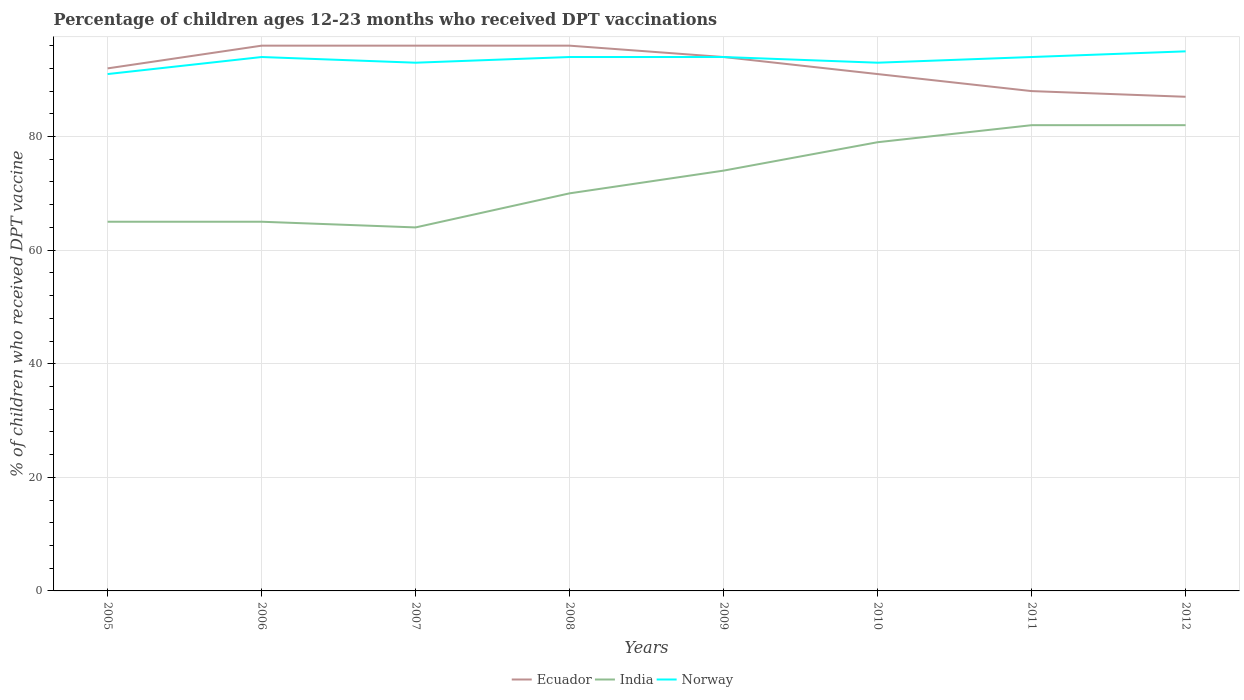Does the line corresponding to Ecuador intersect with the line corresponding to Norway?
Your answer should be compact. Yes. Across all years, what is the maximum percentage of children who received DPT vaccination in Ecuador?
Keep it short and to the point. 87. In which year was the percentage of children who received DPT vaccination in Norway maximum?
Give a very brief answer. 2005. What is the total percentage of children who received DPT vaccination in Ecuador in the graph?
Make the answer very short. 4. What is the difference between the highest and the second highest percentage of children who received DPT vaccination in India?
Provide a short and direct response. 18. What is the difference between the highest and the lowest percentage of children who received DPT vaccination in India?
Provide a short and direct response. 4. Is the percentage of children who received DPT vaccination in India strictly greater than the percentage of children who received DPT vaccination in Norway over the years?
Provide a short and direct response. Yes. Are the values on the major ticks of Y-axis written in scientific E-notation?
Provide a succinct answer. No. Does the graph contain any zero values?
Provide a succinct answer. No. Does the graph contain grids?
Provide a short and direct response. Yes. How many legend labels are there?
Keep it short and to the point. 3. How are the legend labels stacked?
Your response must be concise. Horizontal. What is the title of the graph?
Your answer should be very brief. Percentage of children ages 12-23 months who received DPT vaccinations. What is the label or title of the Y-axis?
Make the answer very short. % of children who received DPT vaccine. What is the % of children who received DPT vaccine in Ecuador in 2005?
Your answer should be very brief. 92. What is the % of children who received DPT vaccine in Norway in 2005?
Offer a very short reply. 91. What is the % of children who received DPT vaccine of Ecuador in 2006?
Your response must be concise. 96. What is the % of children who received DPT vaccine of India in 2006?
Your answer should be compact. 65. What is the % of children who received DPT vaccine of Norway in 2006?
Keep it short and to the point. 94. What is the % of children who received DPT vaccine in Ecuador in 2007?
Your answer should be very brief. 96. What is the % of children who received DPT vaccine in India in 2007?
Make the answer very short. 64. What is the % of children who received DPT vaccine of Norway in 2007?
Your answer should be very brief. 93. What is the % of children who received DPT vaccine in Ecuador in 2008?
Your answer should be compact. 96. What is the % of children who received DPT vaccine of Norway in 2008?
Your response must be concise. 94. What is the % of children who received DPT vaccine of Ecuador in 2009?
Provide a short and direct response. 94. What is the % of children who received DPT vaccine of India in 2009?
Your response must be concise. 74. What is the % of children who received DPT vaccine of Norway in 2009?
Your answer should be compact. 94. What is the % of children who received DPT vaccine of Ecuador in 2010?
Keep it short and to the point. 91. What is the % of children who received DPT vaccine of India in 2010?
Give a very brief answer. 79. What is the % of children who received DPT vaccine in Norway in 2010?
Make the answer very short. 93. What is the % of children who received DPT vaccine of Norway in 2011?
Give a very brief answer. 94. What is the % of children who received DPT vaccine of Ecuador in 2012?
Make the answer very short. 87. Across all years, what is the maximum % of children who received DPT vaccine of Ecuador?
Provide a succinct answer. 96. Across all years, what is the maximum % of children who received DPT vaccine of India?
Your answer should be compact. 82. Across all years, what is the minimum % of children who received DPT vaccine of Norway?
Make the answer very short. 91. What is the total % of children who received DPT vaccine of Ecuador in the graph?
Ensure brevity in your answer.  740. What is the total % of children who received DPT vaccine of India in the graph?
Your answer should be very brief. 581. What is the total % of children who received DPT vaccine of Norway in the graph?
Keep it short and to the point. 748. What is the difference between the % of children who received DPT vaccine in Norway in 2005 and that in 2006?
Your answer should be compact. -3. What is the difference between the % of children who received DPT vaccine of Ecuador in 2005 and that in 2007?
Provide a succinct answer. -4. What is the difference between the % of children who received DPT vaccine in Norway in 2005 and that in 2007?
Your response must be concise. -2. What is the difference between the % of children who received DPT vaccine of India in 2005 and that in 2009?
Provide a short and direct response. -9. What is the difference between the % of children who received DPT vaccine in India in 2005 and that in 2010?
Ensure brevity in your answer.  -14. What is the difference between the % of children who received DPT vaccine of Ecuador in 2005 and that in 2011?
Provide a short and direct response. 4. What is the difference between the % of children who received DPT vaccine in India in 2005 and that in 2011?
Offer a very short reply. -17. What is the difference between the % of children who received DPT vaccine in Norway in 2005 and that in 2011?
Ensure brevity in your answer.  -3. What is the difference between the % of children who received DPT vaccine in Norway in 2005 and that in 2012?
Your response must be concise. -4. What is the difference between the % of children who received DPT vaccine in Ecuador in 2006 and that in 2007?
Your answer should be compact. 0. What is the difference between the % of children who received DPT vaccine of Norway in 2006 and that in 2007?
Your answer should be very brief. 1. What is the difference between the % of children who received DPT vaccine in Ecuador in 2006 and that in 2008?
Ensure brevity in your answer.  0. What is the difference between the % of children who received DPT vaccine of India in 2006 and that in 2008?
Your answer should be compact. -5. What is the difference between the % of children who received DPT vaccine of Norway in 2006 and that in 2008?
Give a very brief answer. 0. What is the difference between the % of children who received DPT vaccine in Ecuador in 2006 and that in 2009?
Provide a short and direct response. 2. What is the difference between the % of children who received DPT vaccine of India in 2006 and that in 2009?
Keep it short and to the point. -9. What is the difference between the % of children who received DPT vaccine of Norway in 2006 and that in 2009?
Ensure brevity in your answer.  0. What is the difference between the % of children who received DPT vaccine in Ecuador in 2006 and that in 2010?
Keep it short and to the point. 5. What is the difference between the % of children who received DPT vaccine in Ecuador in 2006 and that in 2011?
Your answer should be very brief. 8. What is the difference between the % of children who received DPT vaccine in Norway in 2006 and that in 2011?
Offer a terse response. 0. What is the difference between the % of children who received DPT vaccine in Ecuador in 2006 and that in 2012?
Provide a short and direct response. 9. What is the difference between the % of children who received DPT vaccine of India in 2006 and that in 2012?
Make the answer very short. -17. What is the difference between the % of children who received DPT vaccine in Ecuador in 2007 and that in 2008?
Offer a terse response. 0. What is the difference between the % of children who received DPT vaccine of India in 2007 and that in 2008?
Provide a short and direct response. -6. What is the difference between the % of children who received DPT vaccine in Norway in 2007 and that in 2008?
Provide a succinct answer. -1. What is the difference between the % of children who received DPT vaccine in Ecuador in 2007 and that in 2009?
Provide a succinct answer. 2. What is the difference between the % of children who received DPT vaccine in India in 2007 and that in 2009?
Keep it short and to the point. -10. What is the difference between the % of children who received DPT vaccine of Norway in 2007 and that in 2010?
Your answer should be very brief. 0. What is the difference between the % of children who received DPT vaccine in Ecuador in 2007 and that in 2011?
Offer a terse response. 8. What is the difference between the % of children who received DPT vaccine of Norway in 2007 and that in 2011?
Provide a short and direct response. -1. What is the difference between the % of children who received DPT vaccine of Ecuador in 2007 and that in 2012?
Provide a succinct answer. 9. What is the difference between the % of children who received DPT vaccine of India in 2007 and that in 2012?
Provide a succinct answer. -18. What is the difference between the % of children who received DPT vaccine in Norway in 2007 and that in 2012?
Your answer should be compact. -2. What is the difference between the % of children who received DPT vaccine of Ecuador in 2008 and that in 2009?
Make the answer very short. 2. What is the difference between the % of children who received DPT vaccine of India in 2008 and that in 2009?
Give a very brief answer. -4. What is the difference between the % of children who received DPT vaccine in Norway in 2008 and that in 2009?
Your answer should be very brief. 0. What is the difference between the % of children who received DPT vaccine in India in 2008 and that in 2010?
Provide a short and direct response. -9. What is the difference between the % of children who received DPT vaccine of Norway in 2008 and that in 2010?
Keep it short and to the point. 1. What is the difference between the % of children who received DPT vaccine of Norway in 2008 and that in 2011?
Provide a short and direct response. 0. What is the difference between the % of children who received DPT vaccine in Ecuador in 2008 and that in 2012?
Give a very brief answer. 9. What is the difference between the % of children who received DPT vaccine of Ecuador in 2009 and that in 2010?
Give a very brief answer. 3. What is the difference between the % of children who received DPT vaccine of Ecuador in 2009 and that in 2011?
Your response must be concise. 6. What is the difference between the % of children who received DPT vaccine of India in 2009 and that in 2011?
Give a very brief answer. -8. What is the difference between the % of children who received DPT vaccine of Ecuador in 2009 and that in 2012?
Your answer should be very brief. 7. What is the difference between the % of children who received DPT vaccine of Norway in 2009 and that in 2012?
Give a very brief answer. -1. What is the difference between the % of children who received DPT vaccine in Ecuador in 2010 and that in 2011?
Give a very brief answer. 3. What is the difference between the % of children who received DPT vaccine in India in 2010 and that in 2011?
Ensure brevity in your answer.  -3. What is the difference between the % of children who received DPT vaccine of Ecuador in 2010 and that in 2012?
Your answer should be compact. 4. What is the difference between the % of children who received DPT vaccine in Norway in 2010 and that in 2012?
Provide a succinct answer. -2. What is the difference between the % of children who received DPT vaccine of Ecuador in 2011 and that in 2012?
Ensure brevity in your answer.  1. What is the difference between the % of children who received DPT vaccine in India in 2011 and that in 2012?
Your answer should be very brief. 0. What is the difference between the % of children who received DPT vaccine of Ecuador in 2005 and the % of children who received DPT vaccine of India in 2006?
Keep it short and to the point. 27. What is the difference between the % of children who received DPT vaccine in Ecuador in 2005 and the % of children who received DPT vaccine in Norway in 2006?
Offer a very short reply. -2. What is the difference between the % of children who received DPT vaccine in India in 2005 and the % of children who received DPT vaccine in Norway in 2006?
Keep it short and to the point. -29. What is the difference between the % of children who received DPT vaccine in Ecuador in 2005 and the % of children who received DPT vaccine in India in 2008?
Your response must be concise. 22. What is the difference between the % of children who received DPT vaccine of Ecuador in 2005 and the % of children who received DPT vaccine of Norway in 2008?
Offer a very short reply. -2. What is the difference between the % of children who received DPT vaccine in India in 2005 and the % of children who received DPT vaccine in Norway in 2008?
Ensure brevity in your answer.  -29. What is the difference between the % of children who received DPT vaccine of Ecuador in 2005 and the % of children who received DPT vaccine of India in 2010?
Offer a very short reply. 13. What is the difference between the % of children who received DPT vaccine of India in 2005 and the % of children who received DPT vaccine of Norway in 2010?
Provide a succinct answer. -28. What is the difference between the % of children who received DPT vaccine in Ecuador in 2005 and the % of children who received DPT vaccine in Norway in 2011?
Offer a very short reply. -2. What is the difference between the % of children who received DPT vaccine of Ecuador in 2005 and the % of children who received DPT vaccine of India in 2012?
Your response must be concise. 10. What is the difference between the % of children who received DPT vaccine in Ecuador in 2005 and the % of children who received DPT vaccine in Norway in 2012?
Give a very brief answer. -3. What is the difference between the % of children who received DPT vaccine of India in 2005 and the % of children who received DPT vaccine of Norway in 2012?
Provide a short and direct response. -30. What is the difference between the % of children who received DPT vaccine in Ecuador in 2006 and the % of children who received DPT vaccine in India in 2007?
Ensure brevity in your answer.  32. What is the difference between the % of children who received DPT vaccine of Ecuador in 2006 and the % of children who received DPT vaccine of Norway in 2007?
Keep it short and to the point. 3. What is the difference between the % of children who received DPT vaccine of India in 2006 and the % of children who received DPT vaccine of Norway in 2007?
Ensure brevity in your answer.  -28. What is the difference between the % of children who received DPT vaccine of India in 2006 and the % of children who received DPT vaccine of Norway in 2008?
Your response must be concise. -29. What is the difference between the % of children who received DPT vaccine in Ecuador in 2006 and the % of children who received DPT vaccine in India in 2009?
Give a very brief answer. 22. What is the difference between the % of children who received DPT vaccine of India in 2006 and the % of children who received DPT vaccine of Norway in 2010?
Keep it short and to the point. -28. What is the difference between the % of children who received DPT vaccine in Ecuador in 2006 and the % of children who received DPT vaccine in India in 2011?
Your response must be concise. 14. What is the difference between the % of children who received DPT vaccine of Ecuador in 2006 and the % of children who received DPT vaccine of Norway in 2011?
Your answer should be very brief. 2. What is the difference between the % of children who received DPT vaccine of Ecuador in 2006 and the % of children who received DPT vaccine of India in 2012?
Give a very brief answer. 14. What is the difference between the % of children who received DPT vaccine of Ecuador in 2006 and the % of children who received DPT vaccine of Norway in 2012?
Make the answer very short. 1. What is the difference between the % of children who received DPT vaccine of India in 2006 and the % of children who received DPT vaccine of Norway in 2012?
Ensure brevity in your answer.  -30. What is the difference between the % of children who received DPT vaccine of Ecuador in 2007 and the % of children who received DPT vaccine of Norway in 2008?
Provide a short and direct response. 2. What is the difference between the % of children who received DPT vaccine in Ecuador in 2007 and the % of children who received DPT vaccine in Norway in 2009?
Make the answer very short. 2. What is the difference between the % of children who received DPT vaccine of India in 2007 and the % of children who received DPT vaccine of Norway in 2009?
Give a very brief answer. -30. What is the difference between the % of children who received DPT vaccine of Ecuador in 2007 and the % of children who received DPT vaccine of Norway in 2011?
Your answer should be compact. 2. What is the difference between the % of children who received DPT vaccine of India in 2007 and the % of children who received DPT vaccine of Norway in 2011?
Your answer should be very brief. -30. What is the difference between the % of children who received DPT vaccine of India in 2007 and the % of children who received DPT vaccine of Norway in 2012?
Your answer should be compact. -31. What is the difference between the % of children who received DPT vaccine of Ecuador in 2008 and the % of children who received DPT vaccine of India in 2009?
Your answer should be very brief. 22. What is the difference between the % of children who received DPT vaccine in Ecuador in 2008 and the % of children who received DPT vaccine in Norway in 2009?
Make the answer very short. 2. What is the difference between the % of children who received DPT vaccine in India in 2008 and the % of children who received DPT vaccine in Norway in 2010?
Give a very brief answer. -23. What is the difference between the % of children who received DPT vaccine in Ecuador in 2008 and the % of children who received DPT vaccine in Norway in 2011?
Offer a very short reply. 2. What is the difference between the % of children who received DPT vaccine in India in 2008 and the % of children who received DPT vaccine in Norway in 2011?
Keep it short and to the point. -24. What is the difference between the % of children who received DPT vaccine of Ecuador in 2008 and the % of children who received DPT vaccine of Norway in 2012?
Give a very brief answer. 1. What is the difference between the % of children who received DPT vaccine of India in 2008 and the % of children who received DPT vaccine of Norway in 2012?
Your answer should be compact. -25. What is the difference between the % of children who received DPT vaccine in Ecuador in 2009 and the % of children who received DPT vaccine in Norway in 2010?
Offer a terse response. 1. What is the difference between the % of children who received DPT vaccine in India in 2009 and the % of children who received DPT vaccine in Norway in 2010?
Provide a succinct answer. -19. What is the difference between the % of children who received DPT vaccine of Ecuador in 2009 and the % of children who received DPT vaccine of India in 2011?
Provide a succinct answer. 12. What is the difference between the % of children who received DPT vaccine in Ecuador in 2009 and the % of children who received DPT vaccine in Norway in 2011?
Give a very brief answer. 0. What is the difference between the % of children who received DPT vaccine of Ecuador in 2009 and the % of children who received DPT vaccine of India in 2012?
Your response must be concise. 12. What is the difference between the % of children who received DPT vaccine of Ecuador in 2009 and the % of children who received DPT vaccine of Norway in 2012?
Your response must be concise. -1. What is the difference between the % of children who received DPT vaccine in Ecuador in 2010 and the % of children who received DPT vaccine in Norway in 2011?
Provide a short and direct response. -3. What is the difference between the % of children who received DPT vaccine in Ecuador in 2010 and the % of children who received DPT vaccine in Norway in 2012?
Offer a terse response. -4. What is the difference between the % of children who received DPT vaccine of Ecuador in 2011 and the % of children who received DPT vaccine of India in 2012?
Provide a short and direct response. 6. What is the average % of children who received DPT vaccine in Ecuador per year?
Provide a short and direct response. 92.5. What is the average % of children who received DPT vaccine of India per year?
Make the answer very short. 72.62. What is the average % of children who received DPT vaccine in Norway per year?
Ensure brevity in your answer.  93.5. In the year 2006, what is the difference between the % of children who received DPT vaccine in Ecuador and % of children who received DPT vaccine in India?
Your answer should be very brief. 31. In the year 2006, what is the difference between the % of children who received DPT vaccine of Ecuador and % of children who received DPT vaccine of Norway?
Provide a succinct answer. 2. In the year 2006, what is the difference between the % of children who received DPT vaccine in India and % of children who received DPT vaccine in Norway?
Offer a very short reply. -29. In the year 2007, what is the difference between the % of children who received DPT vaccine of Ecuador and % of children who received DPT vaccine of India?
Offer a terse response. 32. In the year 2009, what is the difference between the % of children who received DPT vaccine in Ecuador and % of children who received DPT vaccine in India?
Make the answer very short. 20. In the year 2009, what is the difference between the % of children who received DPT vaccine in Ecuador and % of children who received DPT vaccine in Norway?
Your answer should be compact. 0. In the year 2009, what is the difference between the % of children who received DPT vaccine in India and % of children who received DPT vaccine in Norway?
Offer a very short reply. -20. In the year 2011, what is the difference between the % of children who received DPT vaccine of Ecuador and % of children who received DPT vaccine of India?
Keep it short and to the point. 6. In the year 2012, what is the difference between the % of children who received DPT vaccine of Ecuador and % of children who received DPT vaccine of Norway?
Ensure brevity in your answer.  -8. In the year 2012, what is the difference between the % of children who received DPT vaccine of India and % of children who received DPT vaccine of Norway?
Offer a very short reply. -13. What is the ratio of the % of children who received DPT vaccine of Ecuador in 2005 to that in 2006?
Keep it short and to the point. 0.96. What is the ratio of the % of children who received DPT vaccine in Norway in 2005 to that in 2006?
Offer a terse response. 0.97. What is the ratio of the % of children who received DPT vaccine of India in 2005 to that in 2007?
Make the answer very short. 1.02. What is the ratio of the % of children who received DPT vaccine in Norway in 2005 to that in 2007?
Your answer should be compact. 0.98. What is the ratio of the % of children who received DPT vaccine of Ecuador in 2005 to that in 2008?
Offer a terse response. 0.96. What is the ratio of the % of children who received DPT vaccine of Norway in 2005 to that in 2008?
Your answer should be very brief. 0.97. What is the ratio of the % of children who received DPT vaccine in Ecuador in 2005 to that in 2009?
Your answer should be compact. 0.98. What is the ratio of the % of children who received DPT vaccine of India in 2005 to that in 2009?
Make the answer very short. 0.88. What is the ratio of the % of children who received DPT vaccine in Norway in 2005 to that in 2009?
Your answer should be compact. 0.97. What is the ratio of the % of children who received DPT vaccine of India in 2005 to that in 2010?
Your response must be concise. 0.82. What is the ratio of the % of children who received DPT vaccine of Norway in 2005 to that in 2010?
Your answer should be compact. 0.98. What is the ratio of the % of children who received DPT vaccine in Ecuador in 2005 to that in 2011?
Keep it short and to the point. 1.05. What is the ratio of the % of children who received DPT vaccine of India in 2005 to that in 2011?
Provide a short and direct response. 0.79. What is the ratio of the % of children who received DPT vaccine in Norway in 2005 to that in 2011?
Ensure brevity in your answer.  0.97. What is the ratio of the % of children who received DPT vaccine in Ecuador in 2005 to that in 2012?
Provide a succinct answer. 1.06. What is the ratio of the % of children who received DPT vaccine of India in 2005 to that in 2012?
Offer a very short reply. 0.79. What is the ratio of the % of children who received DPT vaccine of Norway in 2005 to that in 2012?
Make the answer very short. 0.96. What is the ratio of the % of children who received DPT vaccine of India in 2006 to that in 2007?
Offer a terse response. 1.02. What is the ratio of the % of children who received DPT vaccine in Norway in 2006 to that in 2007?
Give a very brief answer. 1.01. What is the ratio of the % of children who received DPT vaccine of Ecuador in 2006 to that in 2008?
Keep it short and to the point. 1. What is the ratio of the % of children who received DPT vaccine in Ecuador in 2006 to that in 2009?
Provide a short and direct response. 1.02. What is the ratio of the % of children who received DPT vaccine of India in 2006 to that in 2009?
Provide a short and direct response. 0.88. What is the ratio of the % of children who received DPT vaccine in Norway in 2006 to that in 2009?
Provide a short and direct response. 1. What is the ratio of the % of children who received DPT vaccine in Ecuador in 2006 to that in 2010?
Give a very brief answer. 1.05. What is the ratio of the % of children who received DPT vaccine of India in 2006 to that in 2010?
Offer a very short reply. 0.82. What is the ratio of the % of children who received DPT vaccine of Norway in 2006 to that in 2010?
Keep it short and to the point. 1.01. What is the ratio of the % of children who received DPT vaccine of Ecuador in 2006 to that in 2011?
Your answer should be very brief. 1.09. What is the ratio of the % of children who received DPT vaccine of India in 2006 to that in 2011?
Your response must be concise. 0.79. What is the ratio of the % of children who received DPT vaccine of Ecuador in 2006 to that in 2012?
Make the answer very short. 1.1. What is the ratio of the % of children who received DPT vaccine of India in 2006 to that in 2012?
Provide a short and direct response. 0.79. What is the ratio of the % of children who received DPT vaccine in Ecuador in 2007 to that in 2008?
Your answer should be very brief. 1. What is the ratio of the % of children who received DPT vaccine in India in 2007 to that in 2008?
Give a very brief answer. 0.91. What is the ratio of the % of children who received DPT vaccine in Ecuador in 2007 to that in 2009?
Ensure brevity in your answer.  1.02. What is the ratio of the % of children who received DPT vaccine in India in 2007 to that in 2009?
Make the answer very short. 0.86. What is the ratio of the % of children who received DPT vaccine of Norway in 2007 to that in 2009?
Offer a terse response. 0.99. What is the ratio of the % of children who received DPT vaccine in Ecuador in 2007 to that in 2010?
Offer a terse response. 1.05. What is the ratio of the % of children who received DPT vaccine of India in 2007 to that in 2010?
Your answer should be very brief. 0.81. What is the ratio of the % of children who received DPT vaccine in Norway in 2007 to that in 2010?
Offer a very short reply. 1. What is the ratio of the % of children who received DPT vaccine in Ecuador in 2007 to that in 2011?
Make the answer very short. 1.09. What is the ratio of the % of children who received DPT vaccine of India in 2007 to that in 2011?
Ensure brevity in your answer.  0.78. What is the ratio of the % of children who received DPT vaccine of Ecuador in 2007 to that in 2012?
Offer a very short reply. 1.1. What is the ratio of the % of children who received DPT vaccine in India in 2007 to that in 2012?
Make the answer very short. 0.78. What is the ratio of the % of children who received DPT vaccine of Norway in 2007 to that in 2012?
Your response must be concise. 0.98. What is the ratio of the % of children who received DPT vaccine in Ecuador in 2008 to that in 2009?
Give a very brief answer. 1.02. What is the ratio of the % of children who received DPT vaccine in India in 2008 to that in 2009?
Offer a very short reply. 0.95. What is the ratio of the % of children who received DPT vaccine in Norway in 2008 to that in 2009?
Ensure brevity in your answer.  1. What is the ratio of the % of children who received DPT vaccine of Ecuador in 2008 to that in 2010?
Give a very brief answer. 1.05. What is the ratio of the % of children who received DPT vaccine in India in 2008 to that in 2010?
Ensure brevity in your answer.  0.89. What is the ratio of the % of children who received DPT vaccine of Norway in 2008 to that in 2010?
Your answer should be very brief. 1.01. What is the ratio of the % of children who received DPT vaccine of Ecuador in 2008 to that in 2011?
Offer a very short reply. 1.09. What is the ratio of the % of children who received DPT vaccine in India in 2008 to that in 2011?
Make the answer very short. 0.85. What is the ratio of the % of children who received DPT vaccine in Norway in 2008 to that in 2011?
Provide a short and direct response. 1. What is the ratio of the % of children who received DPT vaccine of Ecuador in 2008 to that in 2012?
Make the answer very short. 1.1. What is the ratio of the % of children who received DPT vaccine of India in 2008 to that in 2012?
Provide a succinct answer. 0.85. What is the ratio of the % of children who received DPT vaccine in Norway in 2008 to that in 2012?
Your answer should be compact. 0.99. What is the ratio of the % of children who received DPT vaccine of Ecuador in 2009 to that in 2010?
Keep it short and to the point. 1.03. What is the ratio of the % of children who received DPT vaccine of India in 2009 to that in 2010?
Your answer should be very brief. 0.94. What is the ratio of the % of children who received DPT vaccine in Norway in 2009 to that in 2010?
Give a very brief answer. 1.01. What is the ratio of the % of children who received DPT vaccine in Ecuador in 2009 to that in 2011?
Provide a succinct answer. 1.07. What is the ratio of the % of children who received DPT vaccine of India in 2009 to that in 2011?
Offer a very short reply. 0.9. What is the ratio of the % of children who received DPT vaccine in Norway in 2009 to that in 2011?
Ensure brevity in your answer.  1. What is the ratio of the % of children who received DPT vaccine of Ecuador in 2009 to that in 2012?
Offer a very short reply. 1.08. What is the ratio of the % of children who received DPT vaccine in India in 2009 to that in 2012?
Offer a very short reply. 0.9. What is the ratio of the % of children who received DPT vaccine in Norway in 2009 to that in 2012?
Keep it short and to the point. 0.99. What is the ratio of the % of children who received DPT vaccine in Ecuador in 2010 to that in 2011?
Your answer should be compact. 1.03. What is the ratio of the % of children who received DPT vaccine in India in 2010 to that in 2011?
Provide a succinct answer. 0.96. What is the ratio of the % of children who received DPT vaccine in Norway in 2010 to that in 2011?
Provide a succinct answer. 0.99. What is the ratio of the % of children who received DPT vaccine in Ecuador in 2010 to that in 2012?
Provide a succinct answer. 1.05. What is the ratio of the % of children who received DPT vaccine in India in 2010 to that in 2012?
Give a very brief answer. 0.96. What is the ratio of the % of children who received DPT vaccine in Norway in 2010 to that in 2012?
Your response must be concise. 0.98. What is the ratio of the % of children who received DPT vaccine in Ecuador in 2011 to that in 2012?
Make the answer very short. 1.01. What is the ratio of the % of children who received DPT vaccine of Norway in 2011 to that in 2012?
Your answer should be compact. 0.99. What is the difference between the highest and the second highest % of children who received DPT vaccine in Ecuador?
Give a very brief answer. 0. What is the difference between the highest and the second highest % of children who received DPT vaccine of Norway?
Keep it short and to the point. 1. What is the difference between the highest and the lowest % of children who received DPT vaccine of Ecuador?
Make the answer very short. 9. What is the difference between the highest and the lowest % of children who received DPT vaccine of India?
Keep it short and to the point. 18. 